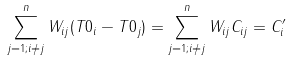<formula> <loc_0><loc_0><loc_500><loc_500>\sum _ { j = 1 ; i \neq j } ^ { n } W _ { i j } ( T 0 _ { i } - T 0 _ { j } ) = \sum _ { j = 1 ; i \neq j } ^ { n } W _ { i j } C _ { i j } = C _ { i } ^ { \prime }</formula> 